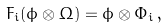Convert formula to latex. <formula><loc_0><loc_0><loc_500><loc_500>F _ { i } ( \phi \otimes \Omega ) = \phi \otimes \Phi _ { i } \, ,</formula> 